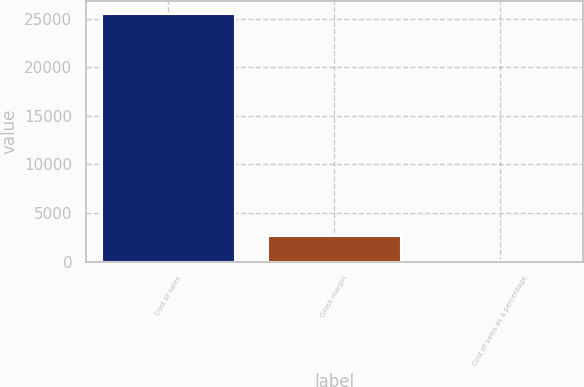Convert chart. <chart><loc_0><loc_0><loc_500><loc_500><bar_chart><fcel>Cost of sales<fcel>Gross margin<fcel>Cost of sales as a percentage<nl><fcel>25501<fcel>2636.05<fcel>95.5<nl></chart> 